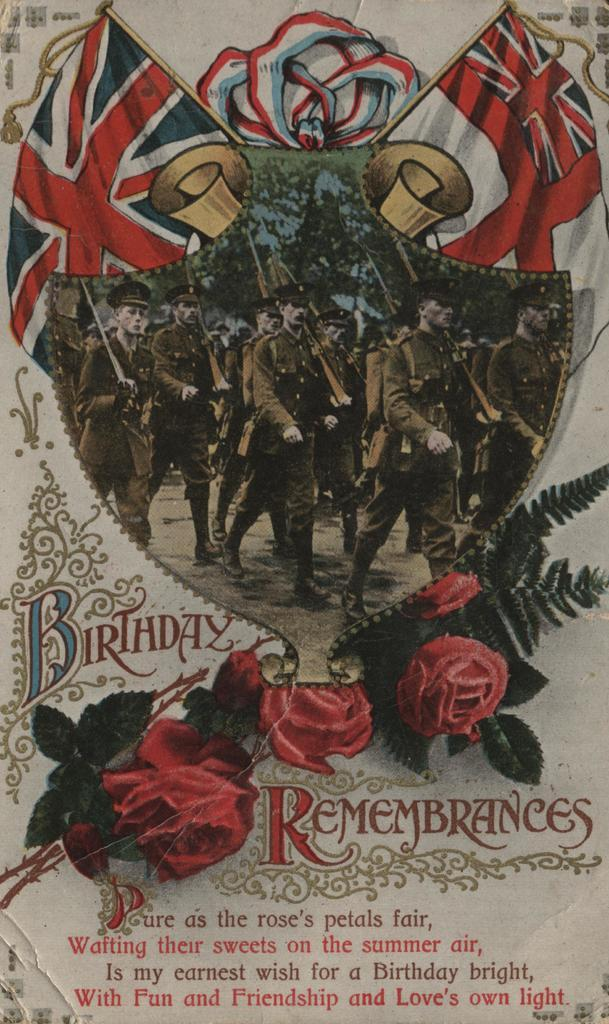<image>
Offer a succinct explanation of the picture presented. A card that says birthsday rememberances with an image of soldiers marching. 